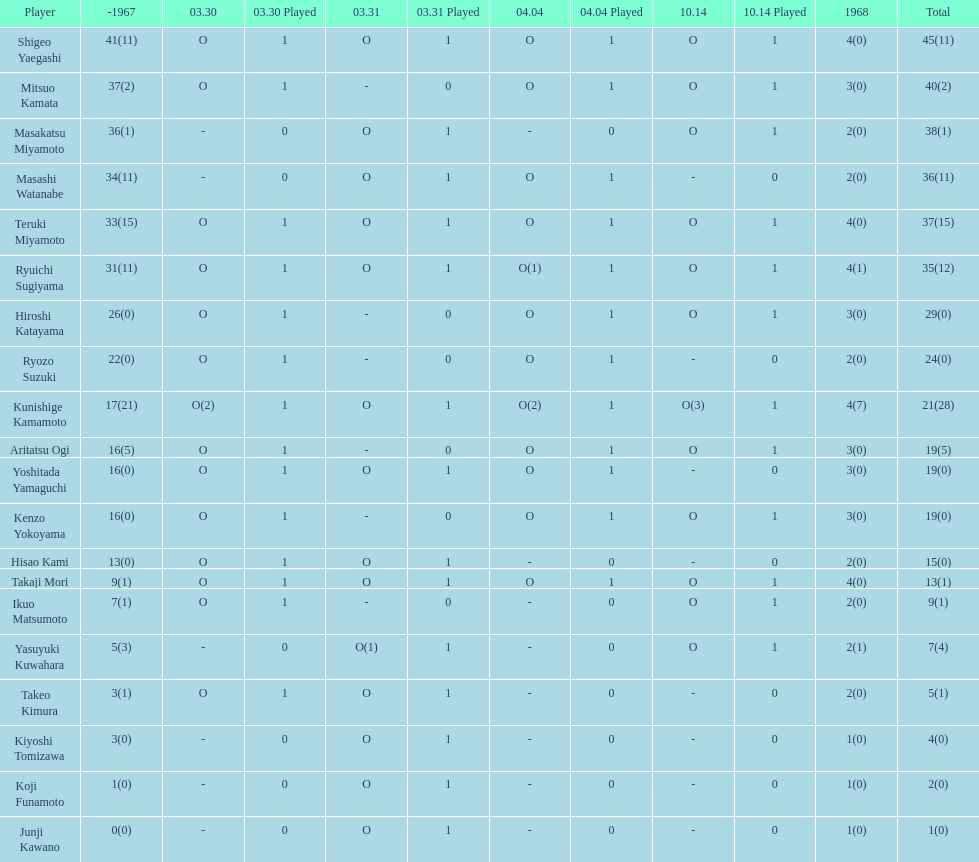Who had more points takaji mori or junji kawano? Takaji Mori. 